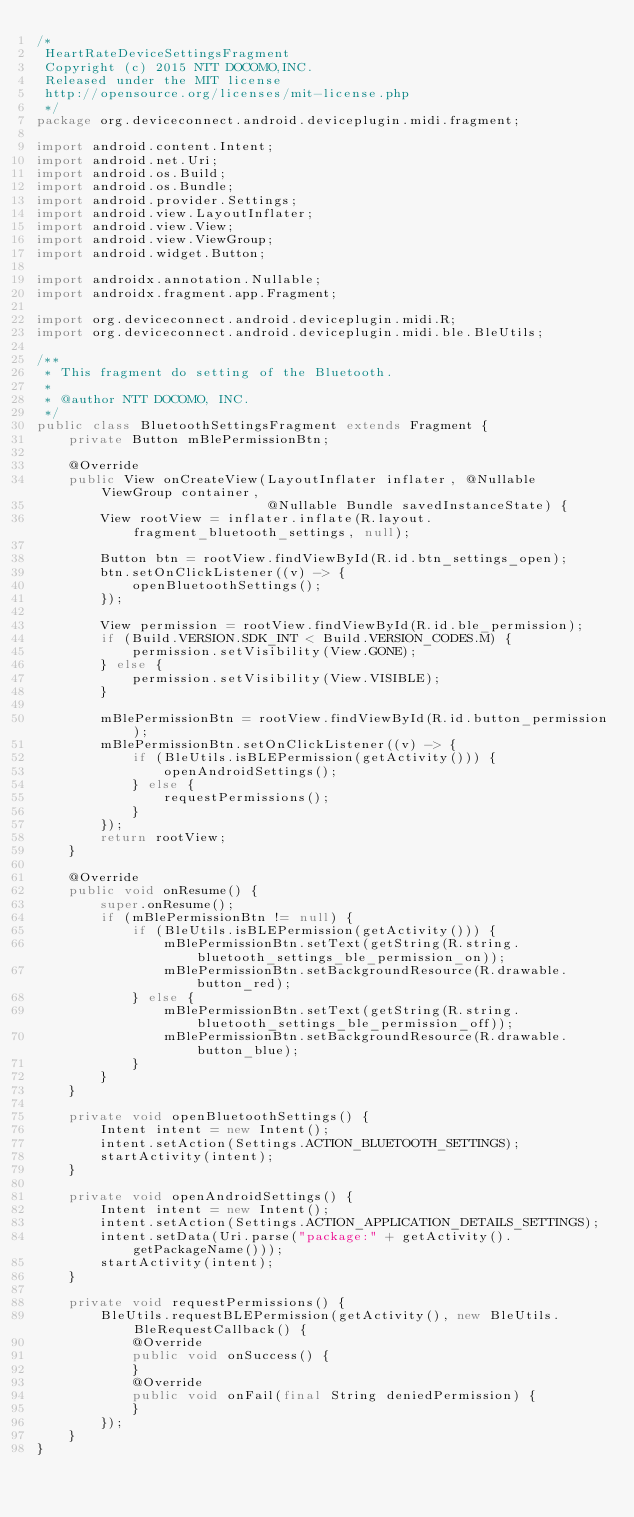<code> <loc_0><loc_0><loc_500><loc_500><_Java_>/*
 HeartRateDeviceSettingsFragment
 Copyright (c) 2015 NTT DOCOMO,INC.
 Released under the MIT license
 http://opensource.org/licenses/mit-license.php
 */
package org.deviceconnect.android.deviceplugin.midi.fragment;

import android.content.Intent;
import android.net.Uri;
import android.os.Build;
import android.os.Bundle;
import android.provider.Settings;
import android.view.LayoutInflater;
import android.view.View;
import android.view.ViewGroup;
import android.widget.Button;

import androidx.annotation.Nullable;
import androidx.fragment.app.Fragment;

import org.deviceconnect.android.deviceplugin.midi.R;
import org.deviceconnect.android.deviceplugin.midi.ble.BleUtils;

/**
 * This fragment do setting of the Bluetooth.
 *
 * @author NTT DOCOMO, INC.
 */
public class BluetoothSettingsFragment extends Fragment {
    private Button mBlePermissionBtn;

    @Override
    public View onCreateView(LayoutInflater inflater, @Nullable ViewGroup container,
                             @Nullable Bundle savedInstanceState) {
        View rootView = inflater.inflate(R.layout.fragment_bluetooth_settings, null);

        Button btn = rootView.findViewById(R.id.btn_settings_open);
        btn.setOnClickListener((v) -> {
            openBluetoothSettings();
        });

        View permission = rootView.findViewById(R.id.ble_permission);
        if (Build.VERSION.SDK_INT < Build.VERSION_CODES.M) {
            permission.setVisibility(View.GONE);
        } else {
            permission.setVisibility(View.VISIBLE);
        }

        mBlePermissionBtn = rootView.findViewById(R.id.button_permission);
        mBlePermissionBtn.setOnClickListener((v) -> {
            if (BleUtils.isBLEPermission(getActivity())) {
                openAndroidSettings();
            } else {
                requestPermissions();
            }
        });
        return rootView;
    }

    @Override
    public void onResume() {
        super.onResume();
        if (mBlePermissionBtn != null) {
            if (BleUtils.isBLEPermission(getActivity())) {
                mBlePermissionBtn.setText(getString(R.string.bluetooth_settings_ble_permission_on));
                mBlePermissionBtn.setBackgroundResource(R.drawable.button_red);
            } else {
                mBlePermissionBtn.setText(getString(R.string.bluetooth_settings_ble_permission_off));
                mBlePermissionBtn.setBackgroundResource(R.drawable.button_blue);
            }
        }
    }

    private void openBluetoothSettings() {
        Intent intent = new Intent();
        intent.setAction(Settings.ACTION_BLUETOOTH_SETTINGS);
        startActivity(intent);
    }

    private void openAndroidSettings() {
        Intent intent = new Intent();
        intent.setAction(Settings.ACTION_APPLICATION_DETAILS_SETTINGS);
        intent.setData(Uri.parse("package:" + getActivity().getPackageName()));
        startActivity(intent);
    }

    private void requestPermissions() {
        BleUtils.requestBLEPermission(getActivity(), new BleUtils.BleRequestCallback() {
            @Override
            public void onSuccess() {
            }
            @Override
            public void onFail(final String deniedPermission) {
            }
        });
    }
}
</code> 